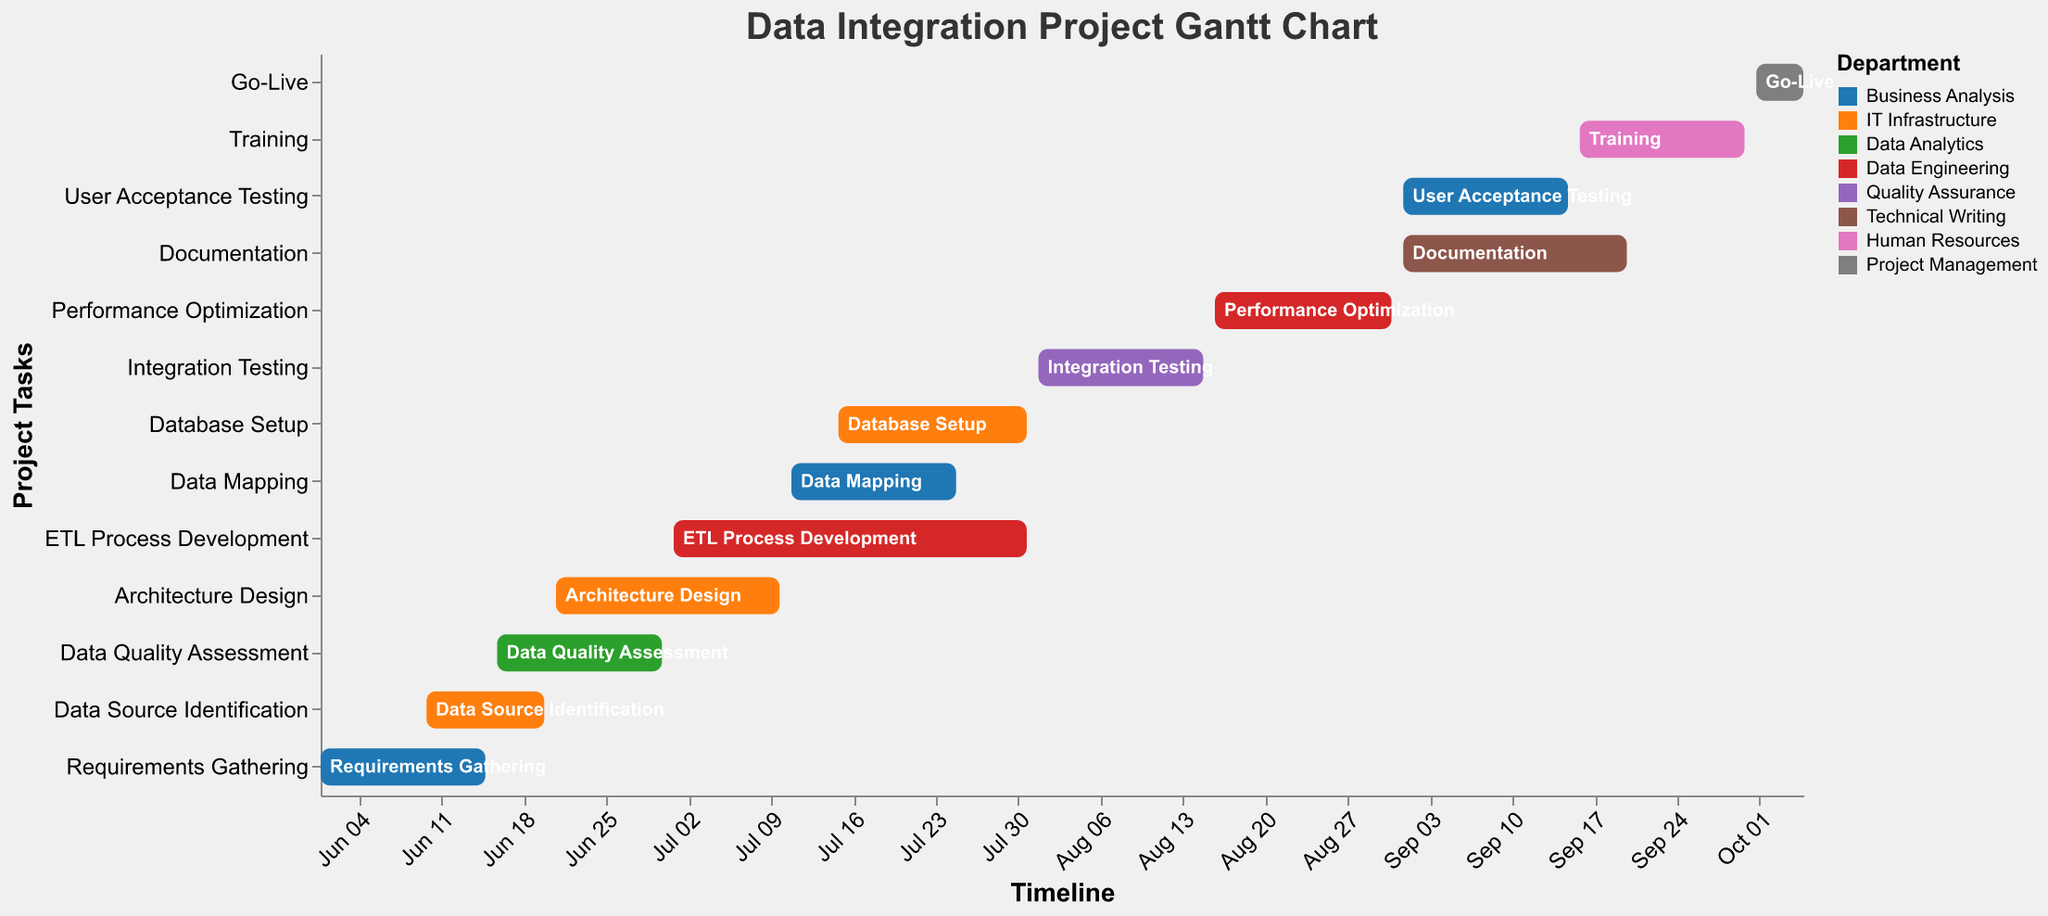What's the title of the Gantt Chart? The title of the Gantt Chart is typically displayed at the top of the figure. In this case, the title is clearly visible at the top of the chart as "Data Integration Project Gantt Chart."
Answer: Data Integration Project Gantt Chart Which department is responsible for the "Architecture Design" task? The color legend at the right indicates which colors correspond to which departments. The "Architecture Design" task bar is colored corresponding to "IT Infrastructure."
Answer: IT Infrastructure When does the "ETL Process Development" start and end? By locating "ETL Process Development" on the vertical axis and checking the start and end dates on the horizontal axis, we can determine the task period. It starts on July 1 and ends on July 31, 2023.
Answer: July 1 to July 31, 2023 Which tasks must be completed before the "Training" task can begin? By examining the dependencies listed for "Training," we see that it follows "User Acceptance Testing" and "Documentation." Both of these must be completed before "Training" starts.
Answer: User Acceptance Testing; Documentation What is the total duration of the "Performance Optimization" task? The "Performance Optimization" task starts on August 16 and ends on August 31, 2023. The total duration is the number of days it spans. Counting the days inclusive, it spans 16 days (from August 16 to 31).
Answer: 16 days Which task has the longest duration? By comparing the start and end dates of all tasks, we find that the "ETL Process Development" task spans from July 1 to July 31, which is 31 days. This is the longest duration among all tasks.
Answer: ETL Process Development How many departments are involved in the entire project? The color legend and the department labels for various tasks indicate the number of distinct departments involved. By counting the unique department names, we find there are 8 departments involved.
Answer: 8 departments Which tasks overlap with "Data Quality Assessment"? By identifying the start and end dates of "Data Quality Assessment" (June 16 to June 30) and comparing them with other tasks' timelines, we see that "Data Source Identification" overlaps from June 16-20 and "Architecture Design" overlaps from June 21-30.
Answer: Data Source Identification, Architecture Design What is the critical path leading to the "Go-Live" task? The critical path includes all tasks that must be completed sequentially leading up to the "Go-Live." It's a logical dependency chain: Requirements Gathering -> Data Quality Assessment -> ETL Process Development -> Integration Testing -> Performance Optimization -> User Acceptance Testing -> Training -> Go-Live.
Answer: Requirements Gathering -> Data Quality Assessment -> ETL Process Development -> Integration Testing -> Performance Optimization -> User Acceptance Testing -> Training -> Go-Live 